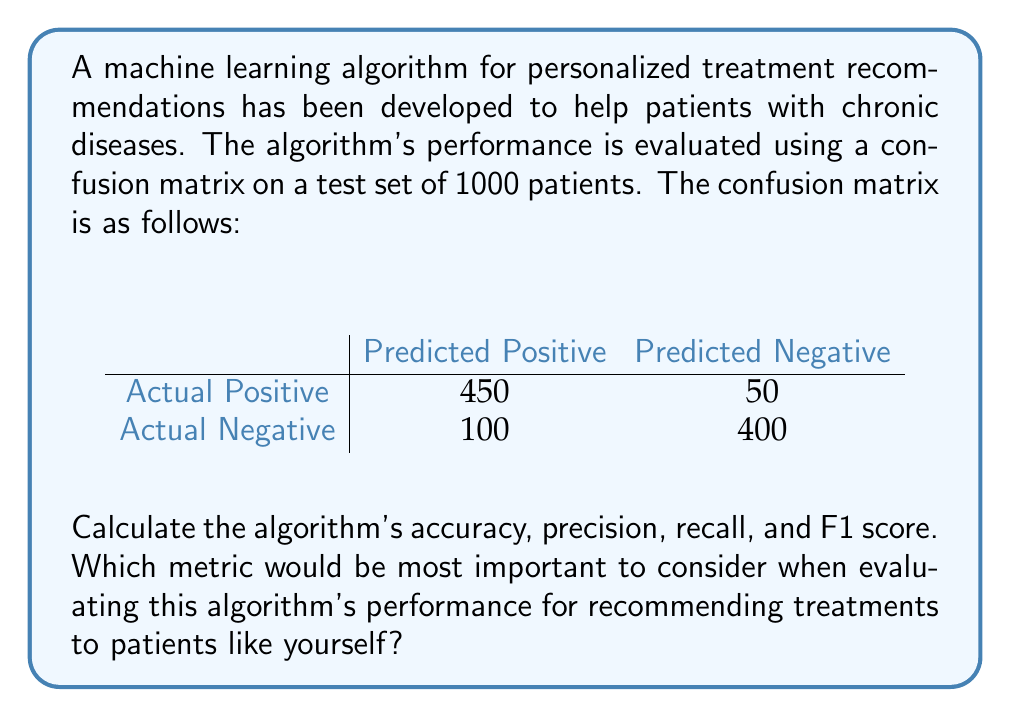Help me with this question. Let's calculate each metric step-by-step:

1. Accuracy:
   Accuracy = (True Positives + True Negatives) / Total
   $$ \text{Accuracy} = \frac{450 + 400}{1000} = 0.85 = 85\% $$

2. Precision:
   Precision = True Positives / (True Positives + False Positives)
   $$ \text{Precision} = \frac{450}{450 + 100} = \frac{450}{550} \approx 0.8182 = 81.82\% $$

3. Recall:
   Recall = True Positives / (True Positives + False Negatives)
   $$ \text{Recall} = \frac{450}{450 + 50} = \frac{450}{500} = 0.90 = 90\% $$

4. F1 Score:
   F1 Score = 2 * (Precision * Recall) / (Precision + Recall)
   $$ \text{F1 Score} = \frac{2 * (0.8182 * 0.90)}{0.8182 + 0.90} \approx 0.8571 = 85.71\% $$

For a patient with a chronic disease determined to live life to the fullest, the most important metric to consider would be recall. Recall measures the algorithm's ability to correctly identify positive cases (i.e., patients who need a specific treatment). A high recall (90% in this case) means the algorithm is less likely to miss patients who require treatment, which is crucial for managing chronic conditions effectively and maintaining quality of life.
Answer: Accuracy: 85%
Precision: 81.82%
Recall: 90%
F1 Score: 85.71%

The most important metric for this scenario is recall (90%). 